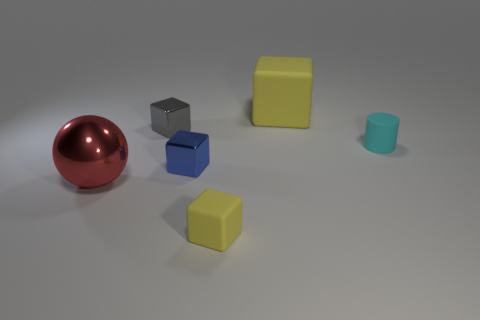How many big cubes have the same color as the tiny matte cube?
Make the answer very short. 1. There is a matte thing that is the same color as the large matte cube; what is its size?
Provide a short and direct response. Small. There is another block that is the same color as the small matte block; what is its material?
Provide a short and direct response. Rubber. Is the number of cyan objects left of the tiny matte cylinder greater than the number of big red metal cubes?
Provide a succinct answer. No. What number of gray rubber cubes have the same size as the red object?
Your response must be concise. 0. Does the yellow thing behind the tiny gray cube have the same size as the metal block that is in front of the cyan rubber thing?
Your answer should be very brief. No. What is the size of the matte thing behind the cylinder?
Your answer should be very brief. Large. What size is the shiny block that is on the right side of the small cube that is to the left of the blue metallic thing?
Offer a terse response. Small. There is a yellow block that is the same size as the cyan rubber cylinder; what is it made of?
Offer a terse response. Rubber. Are there any tiny cyan rubber things on the left side of the gray metal thing?
Ensure brevity in your answer.  No. 